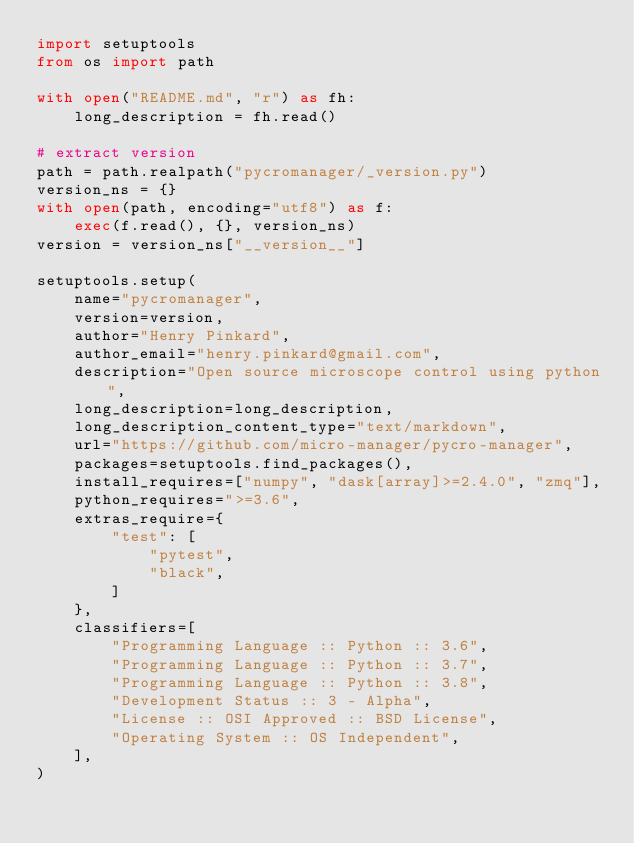<code> <loc_0><loc_0><loc_500><loc_500><_Python_>import setuptools
from os import path

with open("README.md", "r") as fh:
    long_description = fh.read()

# extract version
path = path.realpath("pycromanager/_version.py")
version_ns = {}
with open(path, encoding="utf8") as f:
    exec(f.read(), {}, version_ns)
version = version_ns["__version__"]

setuptools.setup(
    name="pycromanager",
    version=version,
    author="Henry Pinkard",
    author_email="henry.pinkard@gmail.com",
    description="Open source microscope control using python",
    long_description=long_description,
    long_description_content_type="text/markdown",
    url="https://github.com/micro-manager/pycro-manager",
    packages=setuptools.find_packages(),
    install_requires=["numpy", "dask[array]>=2.4.0", "zmq"],
    python_requires=">=3.6",
    extras_require={
        "test": [
            "pytest",
            "black",
        ]
    },
    classifiers=[
        "Programming Language :: Python :: 3.6",
        "Programming Language :: Python :: 3.7",
        "Programming Language :: Python :: 3.8",
        "Development Status :: 3 - Alpha",
        "License :: OSI Approved :: BSD License",
        "Operating System :: OS Independent",
    ],
)
</code> 